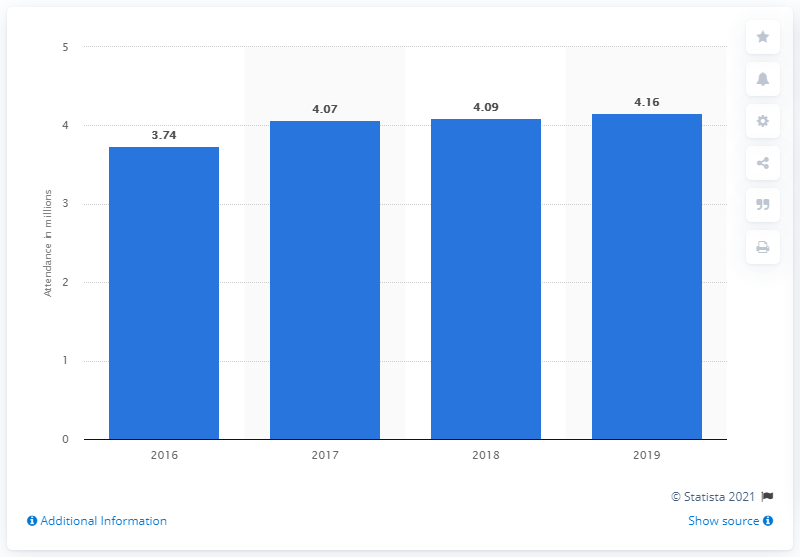Indicate a few pertinent items in this graphic. In 2019, the number of spectators who attended Formula 1 races was approximately 4.16 million. 